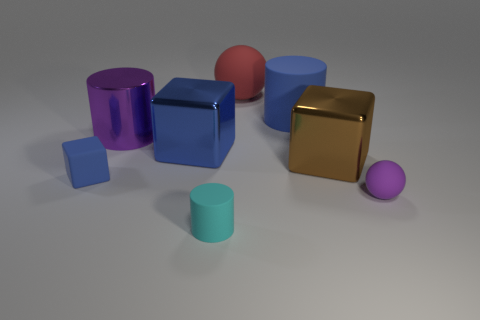Subtract 1 blocks. How many blocks are left? 2 Add 1 tiny blue things. How many objects exist? 9 Subtract all balls. How many objects are left? 6 Subtract all big brown rubber cubes. Subtract all large brown things. How many objects are left? 7 Add 3 big blue rubber cylinders. How many big blue rubber cylinders are left? 4 Add 3 big blue cylinders. How many big blue cylinders exist? 4 Subtract 1 brown cubes. How many objects are left? 7 